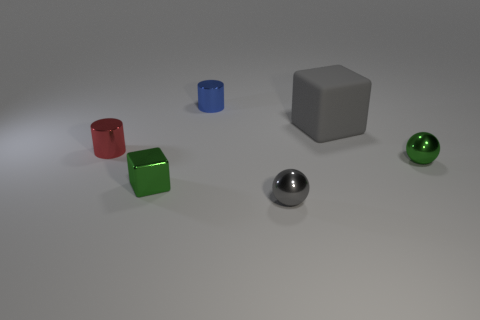Add 2 small cyan blocks. How many objects exist? 8 Subtract all cubes. How many objects are left? 4 Subtract 0 brown cylinders. How many objects are left? 6 Subtract all large cyan rubber spheres. Subtract all gray balls. How many objects are left? 5 Add 4 small green balls. How many small green balls are left? 5 Add 2 small shiny blocks. How many small shiny blocks exist? 3 